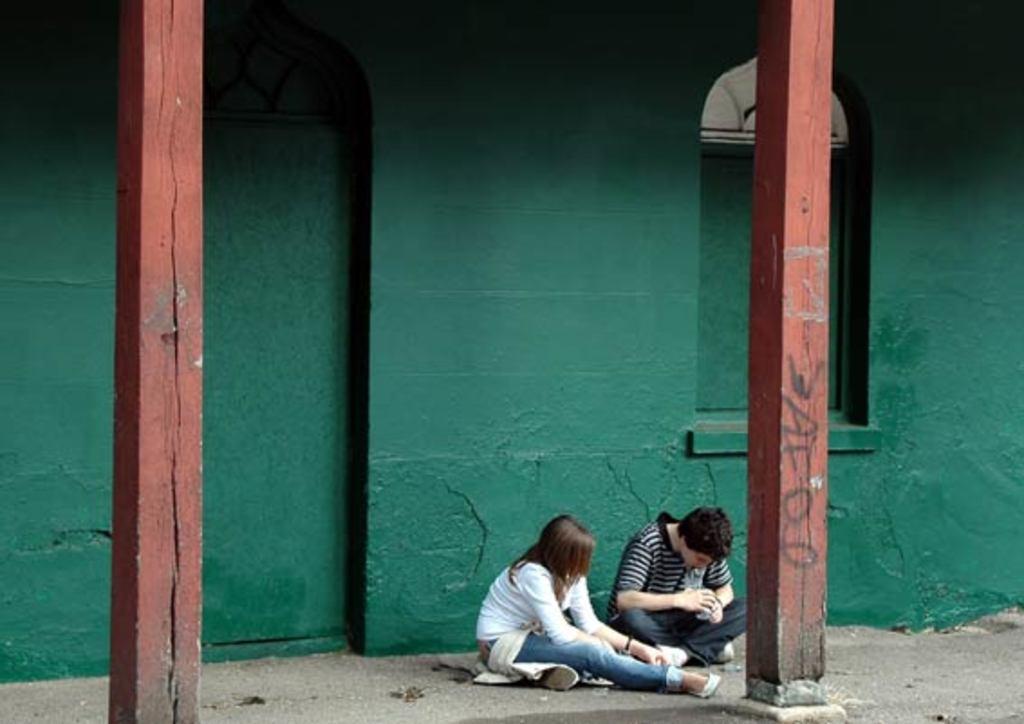In one or two sentences, can you explain what this image depicts? In this image we can see two people sitting near the green wall, two pillars, one man holding one object and some text on the pillar on the right side of the image. 